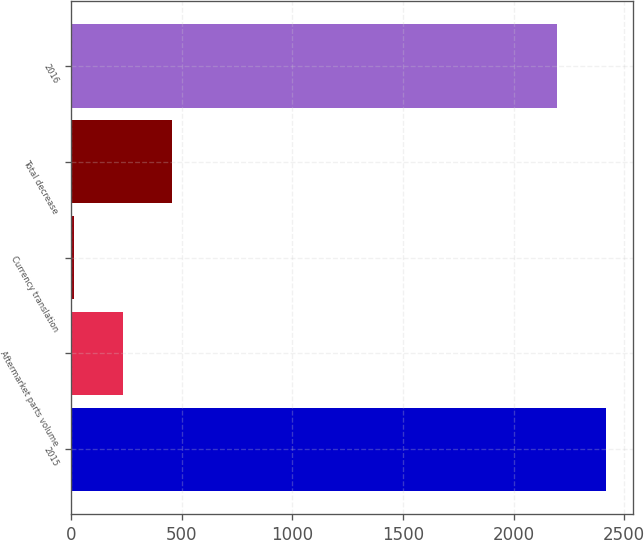Convert chart to OTSL. <chart><loc_0><loc_0><loc_500><loc_500><bar_chart><fcel>2015<fcel>Aftermarket parts volume<fcel>Currency translation<fcel>Total decrease<fcel>2016<nl><fcel>2417.72<fcel>234.22<fcel>12.2<fcel>456.24<fcel>2195.7<nl></chart> 